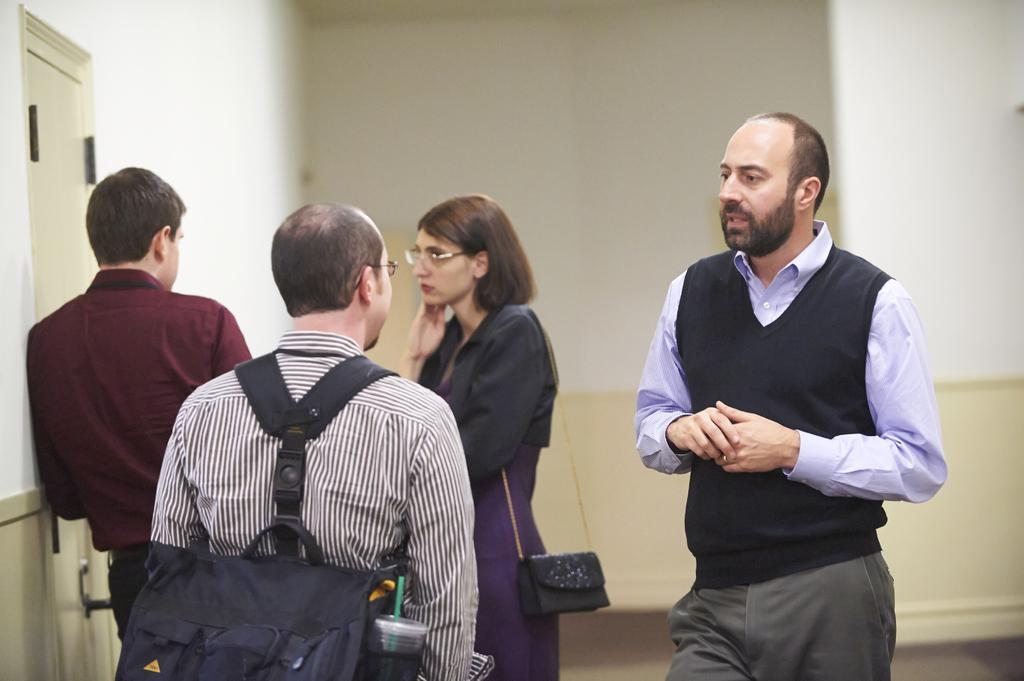What are the people in the image doing? The persons standing in the center of the image are talking with each other. Can you describe the background of the image? There is a wall in the background of the image. What architectural feature is present on the left side of the image? There is a door on the left side of the image. What type of frog can be seen wearing a scarf in the image? There is no frog present in the image, let alone one wearing a scarf. 